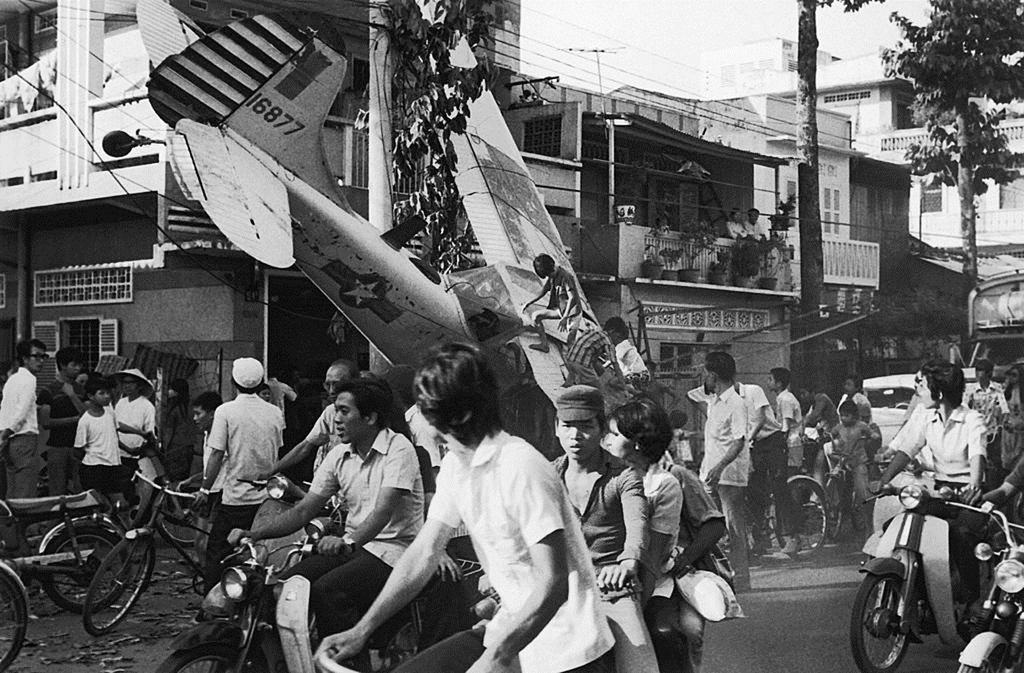What is the color scheme of the image? The image is black and white. Where does the scene take place? The image is an outdoor scene. What can be seen at the top of the image? The sky is visible at the top of the image. What type of structures are present in the image? There are buildings in the image. What activity is taking place on the road in the image? There are persons riding vehicles on the road in the image. What type of bells can be heard ringing in the image? There are no bells present in the image, and therefore no sound can be heard. Can you tell me how many dolls are sitting on the buildings in the image? There are no dolls present in the image; only buildings and persons riding vehicles are visible. 